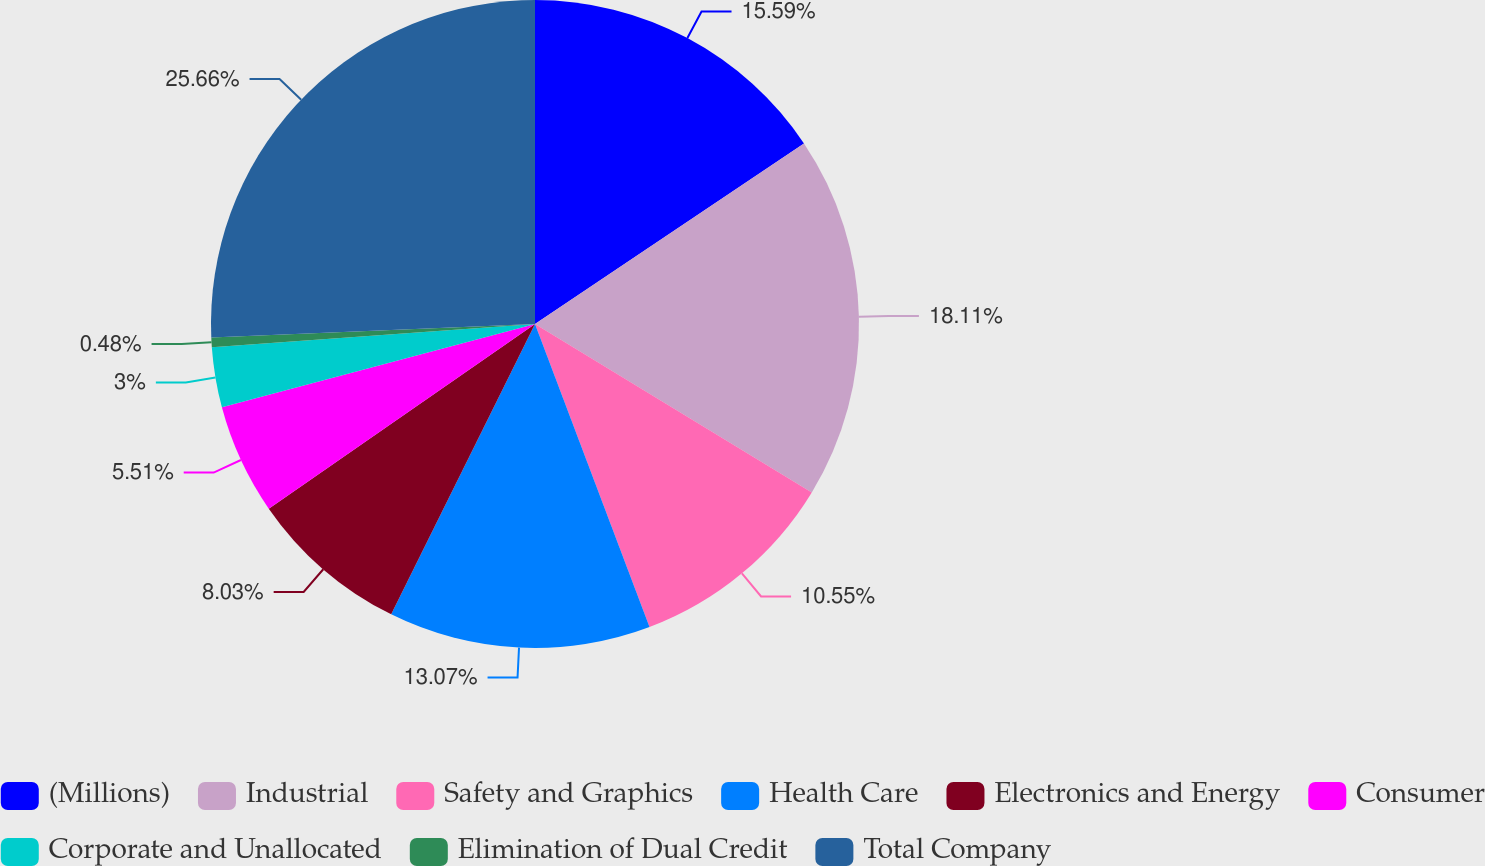<chart> <loc_0><loc_0><loc_500><loc_500><pie_chart><fcel>(Millions)<fcel>Industrial<fcel>Safety and Graphics<fcel>Health Care<fcel>Electronics and Energy<fcel>Consumer<fcel>Corporate and Unallocated<fcel>Elimination of Dual Credit<fcel>Total Company<nl><fcel>15.59%<fcel>18.11%<fcel>10.55%<fcel>13.07%<fcel>8.03%<fcel>5.51%<fcel>3.0%<fcel>0.48%<fcel>25.66%<nl></chart> 